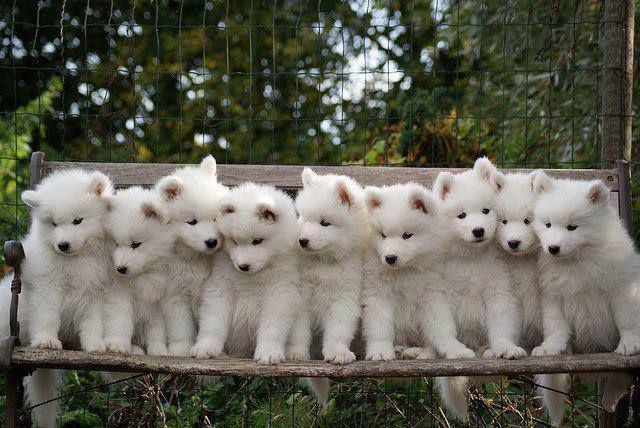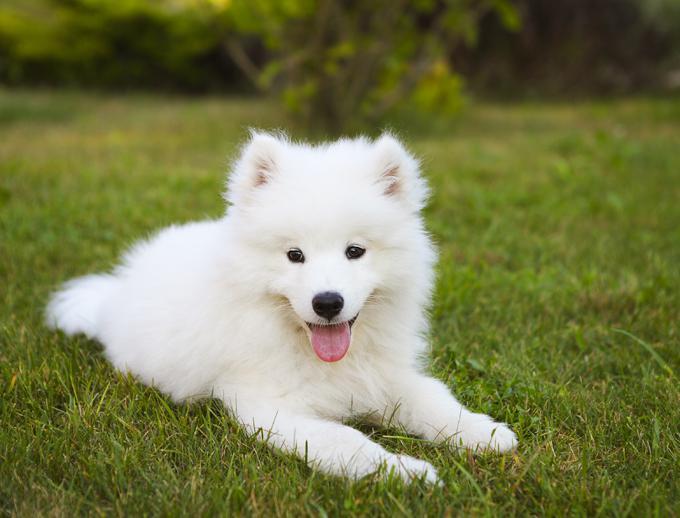The first image is the image on the left, the second image is the image on the right. For the images shown, is this caption "An image shows at least one dog running toward the camera." true? Answer yes or no. No. 